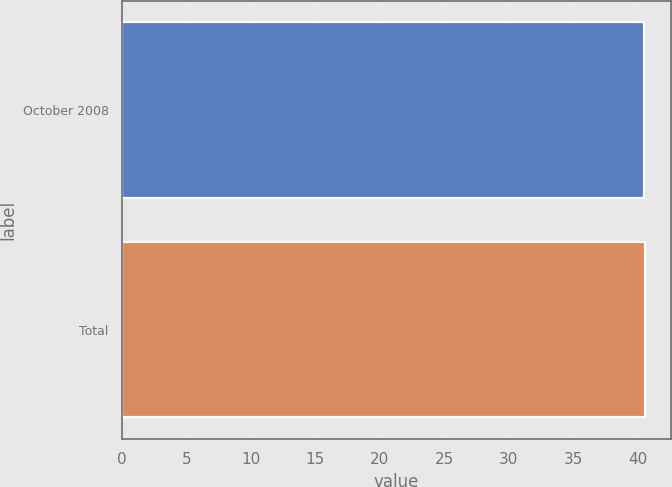Convert chart. <chart><loc_0><loc_0><loc_500><loc_500><bar_chart><fcel>October 2008<fcel>Total<nl><fcel>40.47<fcel>40.57<nl></chart> 